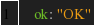Convert code to text. <code><loc_0><loc_0><loc_500><loc_500><_YAML_>    ok: "OK"
</code> 